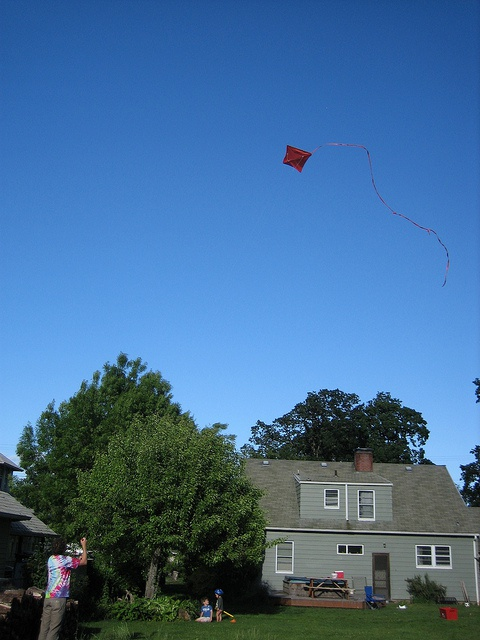Describe the objects in this image and their specific colors. I can see people in blue, gray, black, darkgray, and brown tones, kite in blue, maroon, gray, and black tones, chair in blue, navy, black, gray, and darkblue tones, people in blue, darkgray, and gray tones, and people in blue, black, gray, and maroon tones in this image. 